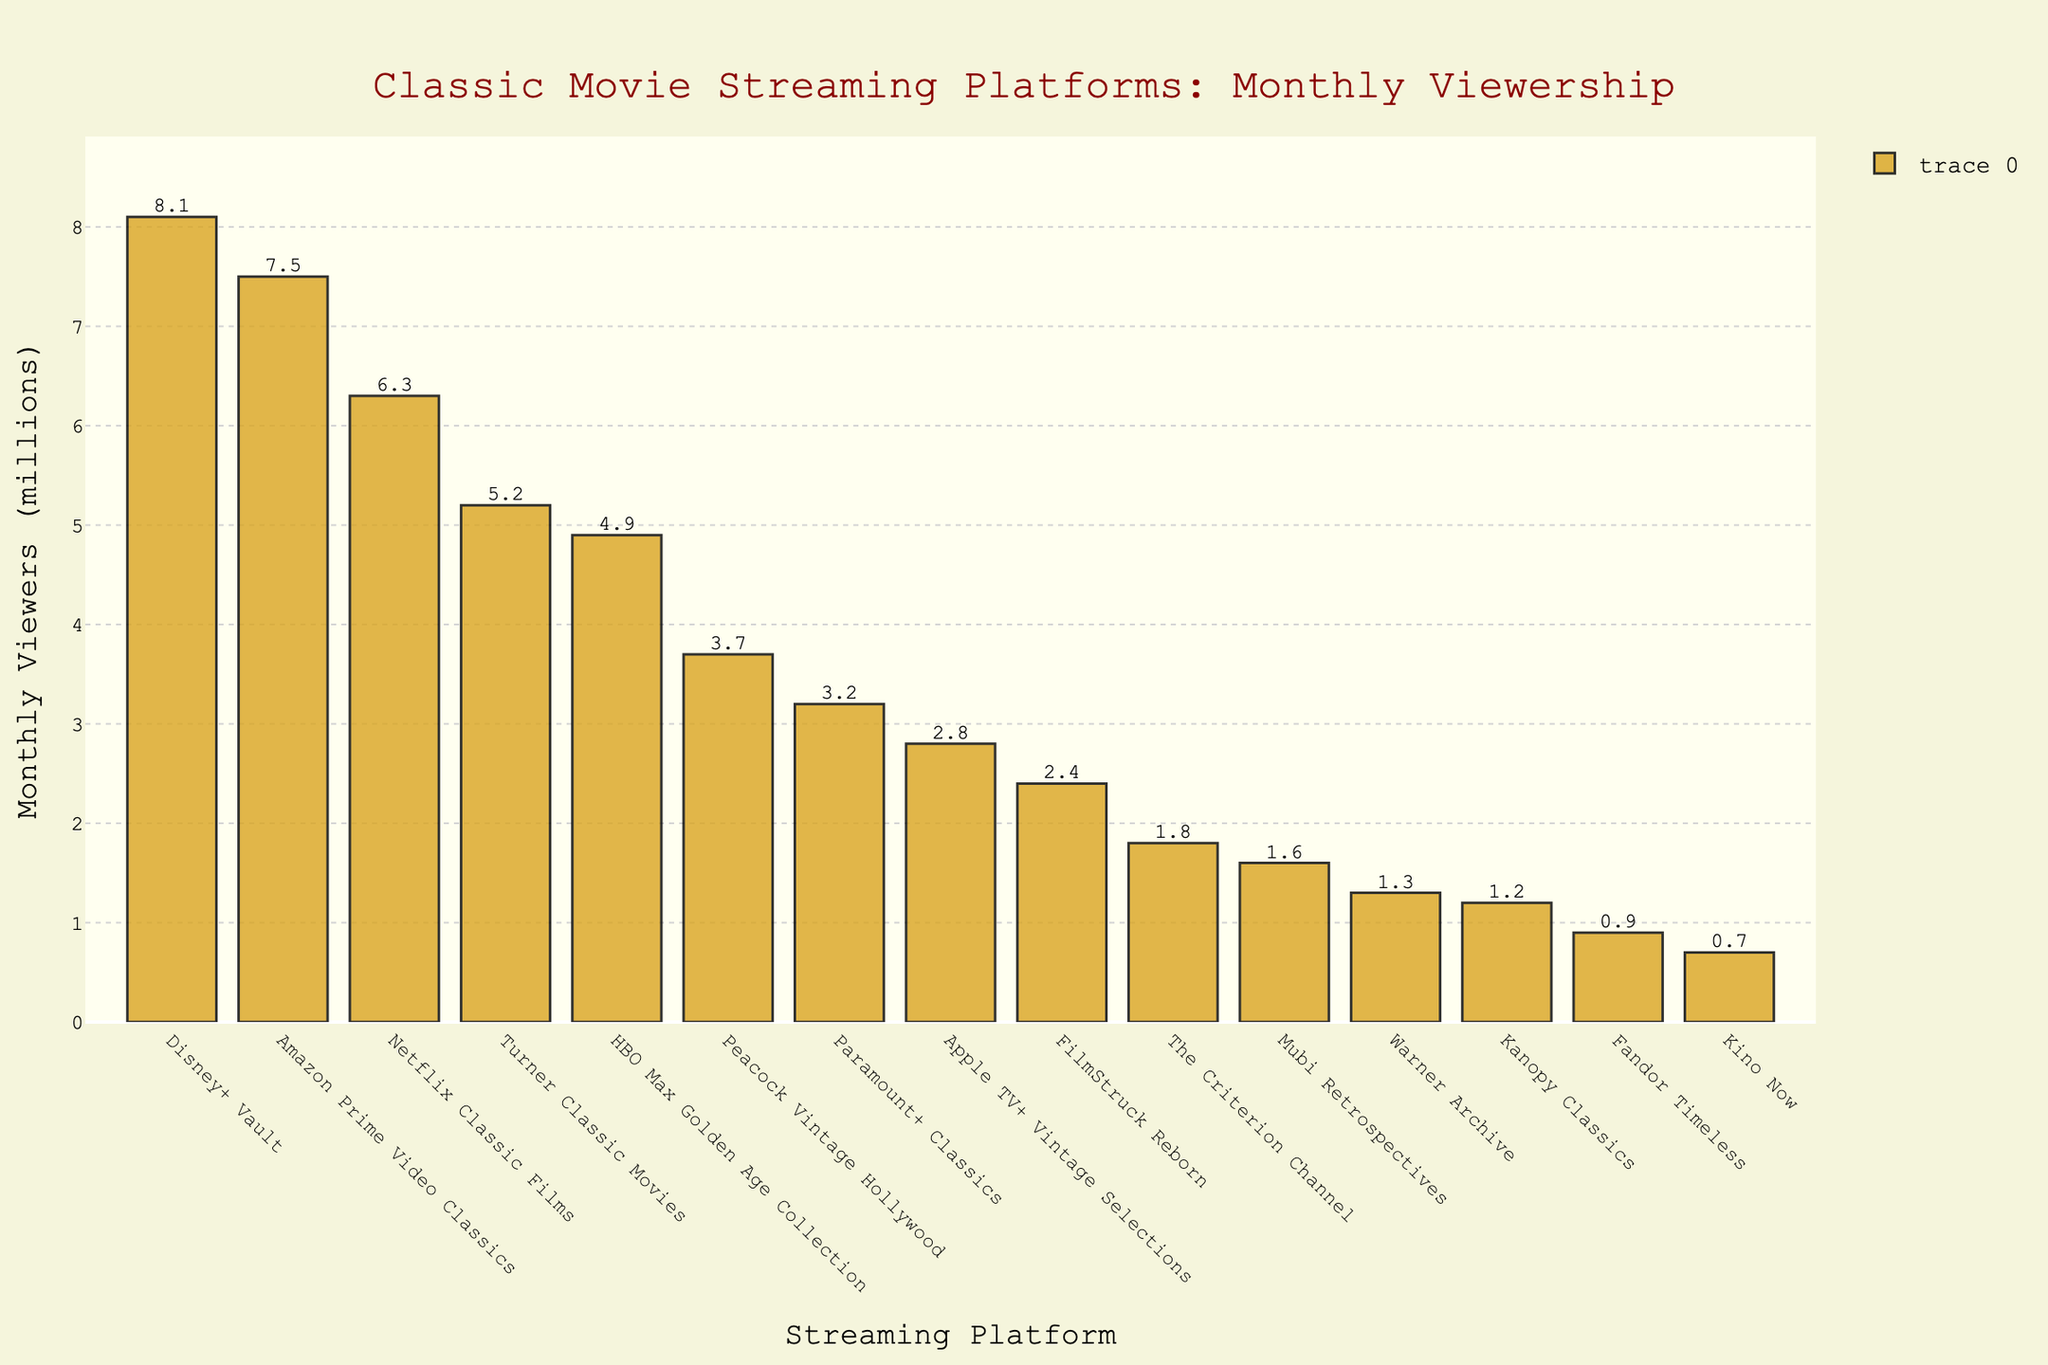Which streaming platform has the highest monthly viewership for classic movies? Look for the tallest bar in the chart. The bar for Disney+ Vault is the highest, indicating it has the highest monthly viewership.
Answer: Disney+ Vault Which platform has a lower viewership: Kanopy Classics or Mubi Retrospectives? Compare the heights of the bars for Kanopy Classics and Mubi Retrospectives. The bar for Kanopy Classics is shorter, indicating it has the lower viewership.
Answer: Kanopy Classics What's the total monthly viewership for Turner Classic Movies and HBO Max Golden Age Collection combined? Add the values for Turner Classic Movies (5.2 million) and HBO Max Golden Age Collection (4.9 million). 5.2 + 4.9 = 10.1 million.
Answer: 10.1 million Does Amazon Prime Video Classics have more monthly viewers than Netflix Classic Films? Compare the heights of the bars for Amazon Prime Video Classics and Netflix Classic Films. Amazon Prime Video Classics has a taller bar, indicating more viewership.
Answer: Yes What is the average monthly viewership of platforms with fewer than 2 million viewers? Sum the viewership numbers for platforms with fewer than 2 million viewers: Criterion Channel (1.8), Kanopy Classics (1.2), Mubi Retrospectives (1.6), Fandor Timeless (0.9), Kino Now (0.7), Warner Archive (1.3). The total is 1.8 + 1.2 + 1.6 + 0.9 + 0.7 + 1.3 = 7.5 million. There are 6 platforms, so the average is 7.5 / 6 = 1.25 million.
Answer: 1.25 million Which streaming platform has closer monthly viewership to 4 million: Peacock Vintage Hollywood or Apple TV+ Vintage Selections? Compare the viewership numbers for Peacock Vintage Hollywood (3.7 million) and Apple TV+ Vintage Selections (2.8 million) with 4 million. Peacock Vintage Hollywood is closer to 4 million.
Answer: Peacock Vintage Hollywood Which two platforms have a combined viewership nearest to 10 million? Evaluate pairs of platforms and their combined viewership: Disney+ Vault (8.1) and Kino Now (0.7) = 8.8 million; Amazon Prime Video Classics (7.5) and FilmStruck Reborn (2.4) = 9.9 million; Amazon Prime Video Classics (7.5) and Paramount+ Classics (3.2) = 10.7 million; etc. The closest combined viewership is Amazon Prime Video Classics and FilmStruck Reborn.
Answer: Amazon Prime Video Classics and FilmStruck Reborn Between Criterion Channel and Warner Archive, which platform has more monthly viewers? Compare the heights of the bars for Criterion Channel and Warner Archive. The bar for Criterion Channel is higher, indicating more viewership.
Answer: Criterion Channel How many platforms have monthly viewership greater than 5 million? Look at the bars that exceed 5 million viewers: Turner Classic Movies, Amazon Prime Video Classics, Netflix Classic Films, Disney+ Vault. There are 4 platforms.
Answer: 4 platforms 